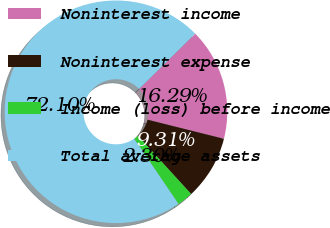<chart> <loc_0><loc_0><loc_500><loc_500><pie_chart><fcel>Noninterest income<fcel>Noninterest expense<fcel>Income (loss) before income<fcel>Total average assets<nl><fcel>16.29%<fcel>9.31%<fcel>2.3%<fcel>72.11%<nl></chart> 